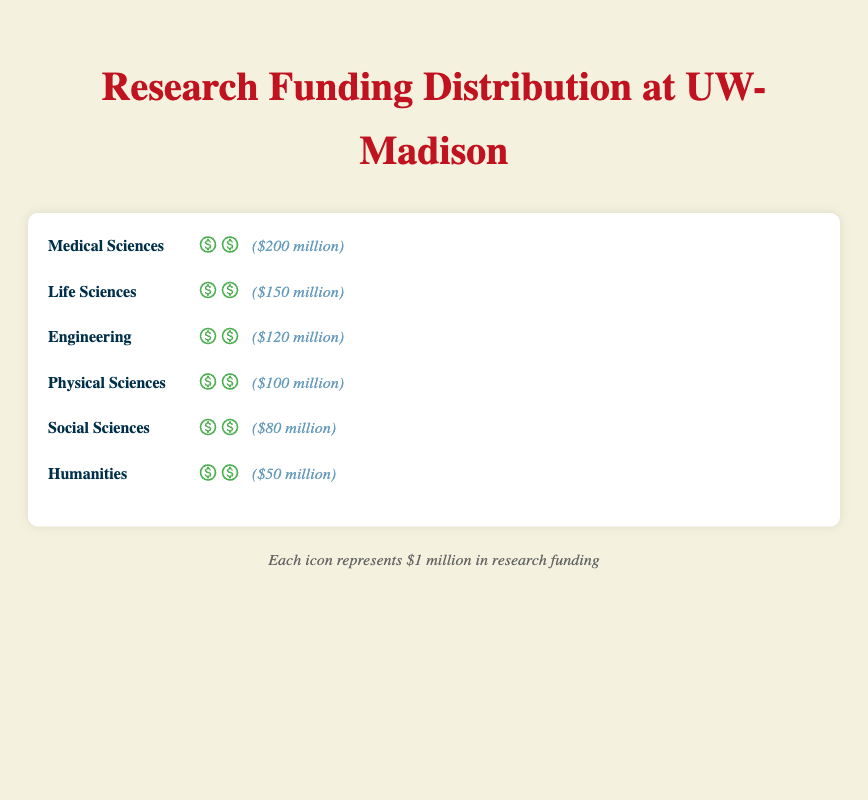What's the title of the figure? The title is located at the top of the figure and is meant to provide a concise description of what the figure represents. By reading it, one can understand the main subject of the chart.
Answer: Research Funding Distribution at UW-Madison How much funding does the field with the least amount receive? To find the field with the least funding, look at the fields listed and count their icons. Humanities has the fewest icons, indicating the least funding.
Answer: $50 million Which field has the highest amount of research funding? By comparing the number of icons representing dollar bills for each field, the one with the most icons has the highest funding. Medical Sciences has the most icons.
Answer: Medical Sciences How much more funding does Medical Sciences receive compared to Social Sciences? Calculate the difference in funding represented by the icons between Medical Sciences and Social Sciences. Medical Sciences has $200 million and Social Sciences has $80 million. The difference is $200 million - $80 million.
Answer: $120 million What is the total amount of research funding across all fields? Sum the funding amounts of all the fields. The sums are: 200 + 150 + 120 + 100 + 80 + 50. Adding these together gives the total funding.
Answer: $700 million Which field receives more funding: Engineering or Physical Sciences? Compare the number of funding icons for Engineering and Physical Sciences. Engineering has 120 icons, and Physical Sciences has 100 icons.
Answer: Engineering Which field has the second highest amount of research funding? By ordering the fields according to the number of icons and funding amounts, the field with the second highest is Life Sciences.
Answer: Life Sciences In terms of funding, how does the Social Sciences field compare to the Engineering field? Compare the number of funding icons (or total funding) between Social Sciences and Engineering. Social Sciences has $80 million, while Engineering has $120 million. Thus, Engineering receives more funding.
Answer: Social Sciences receives less funding What is the combined funding for Life Sciences and Humanities? Sum the funding amounts for Life Sciences and Humanities. Life Sciences has $150 million and Humanities has $50 million. Adding these together gives $150 million + $50 million.
Answer: $200 million What is the average funding allocated to each field? First, find the total funding by summing the amounts of all the fields, which is $700 million. Then, divide this total by the number of fields, 6. The average funding is $700 million / 6.
Answer: $116.67 million 